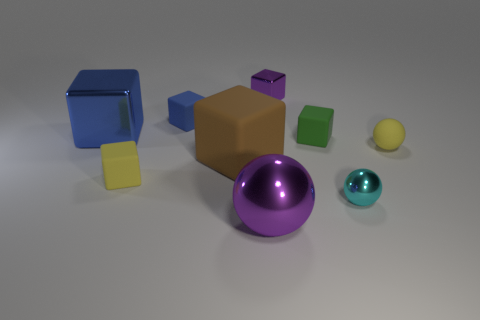Subtract all tiny balls. How many balls are left? 1 Add 1 blue things. How many objects exist? 10 Subtract all yellow balls. How many balls are left? 2 Subtract 1 blocks. How many blocks are left? 5 Add 4 yellow matte things. How many yellow matte things exist? 6 Subtract 0 brown balls. How many objects are left? 9 Subtract all balls. How many objects are left? 6 Subtract all green balls. Subtract all yellow blocks. How many balls are left? 3 Subtract all gray balls. How many green cubes are left? 1 Subtract all big gray matte balls. Subtract all tiny cyan shiny balls. How many objects are left? 8 